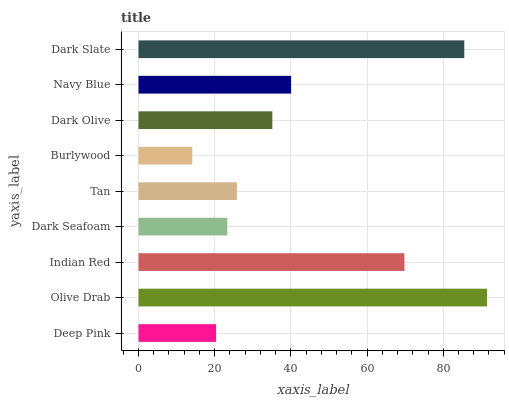Is Burlywood the minimum?
Answer yes or no. Yes. Is Olive Drab the maximum?
Answer yes or no. Yes. Is Indian Red the minimum?
Answer yes or no. No. Is Indian Red the maximum?
Answer yes or no. No. Is Olive Drab greater than Indian Red?
Answer yes or no. Yes. Is Indian Red less than Olive Drab?
Answer yes or no. Yes. Is Indian Red greater than Olive Drab?
Answer yes or no. No. Is Olive Drab less than Indian Red?
Answer yes or no. No. Is Dark Olive the high median?
Answer yes or no. Yes. Is Dark Olive the low median?
Answer yes or no. Yes. Is Tan the high median?
Answer yes or no. No. Is Tan the low median?
Answer yes or no. No. 